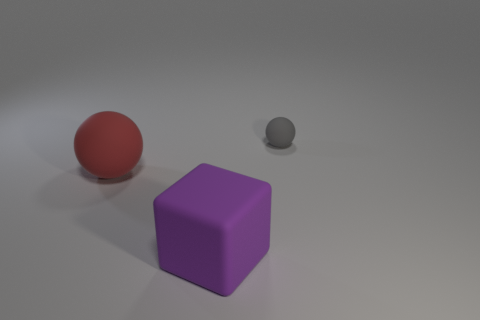Subtract all red spheres. How many spheres are left? 1 Add 3 rubber things. How many objects exist? 6 Subtract 0 blue cylinders. How many objects are left? 3 Subtract all balls. How many objects are left? 1 Subtract 1 cubes. How many cubes are left? 0 Subtract all gray spheres. Subtract all gray blocks. How many spheres are left? 1 Subtract all tiny red things. Subtract all red rubber spheres. How many objects are left? 2 Add 1 balls. How many balls are left? 3 Add 2 gray rubber spheres. How many gray rubber spheres exist? 3 